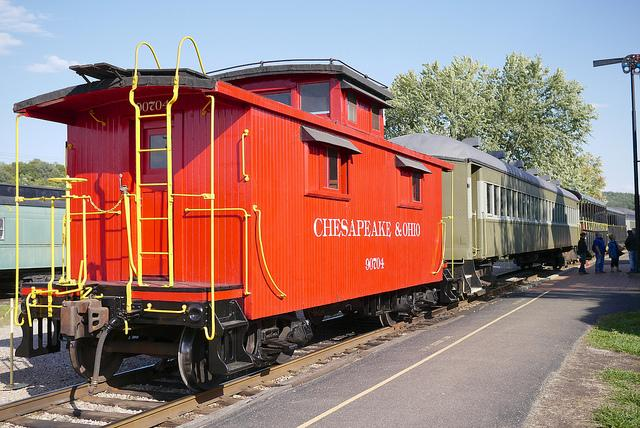The Chesapeake and Ohio Railway was a Class I railroad formed when? Please explain your reasoning. 1869. The railway was formed in 1869. 